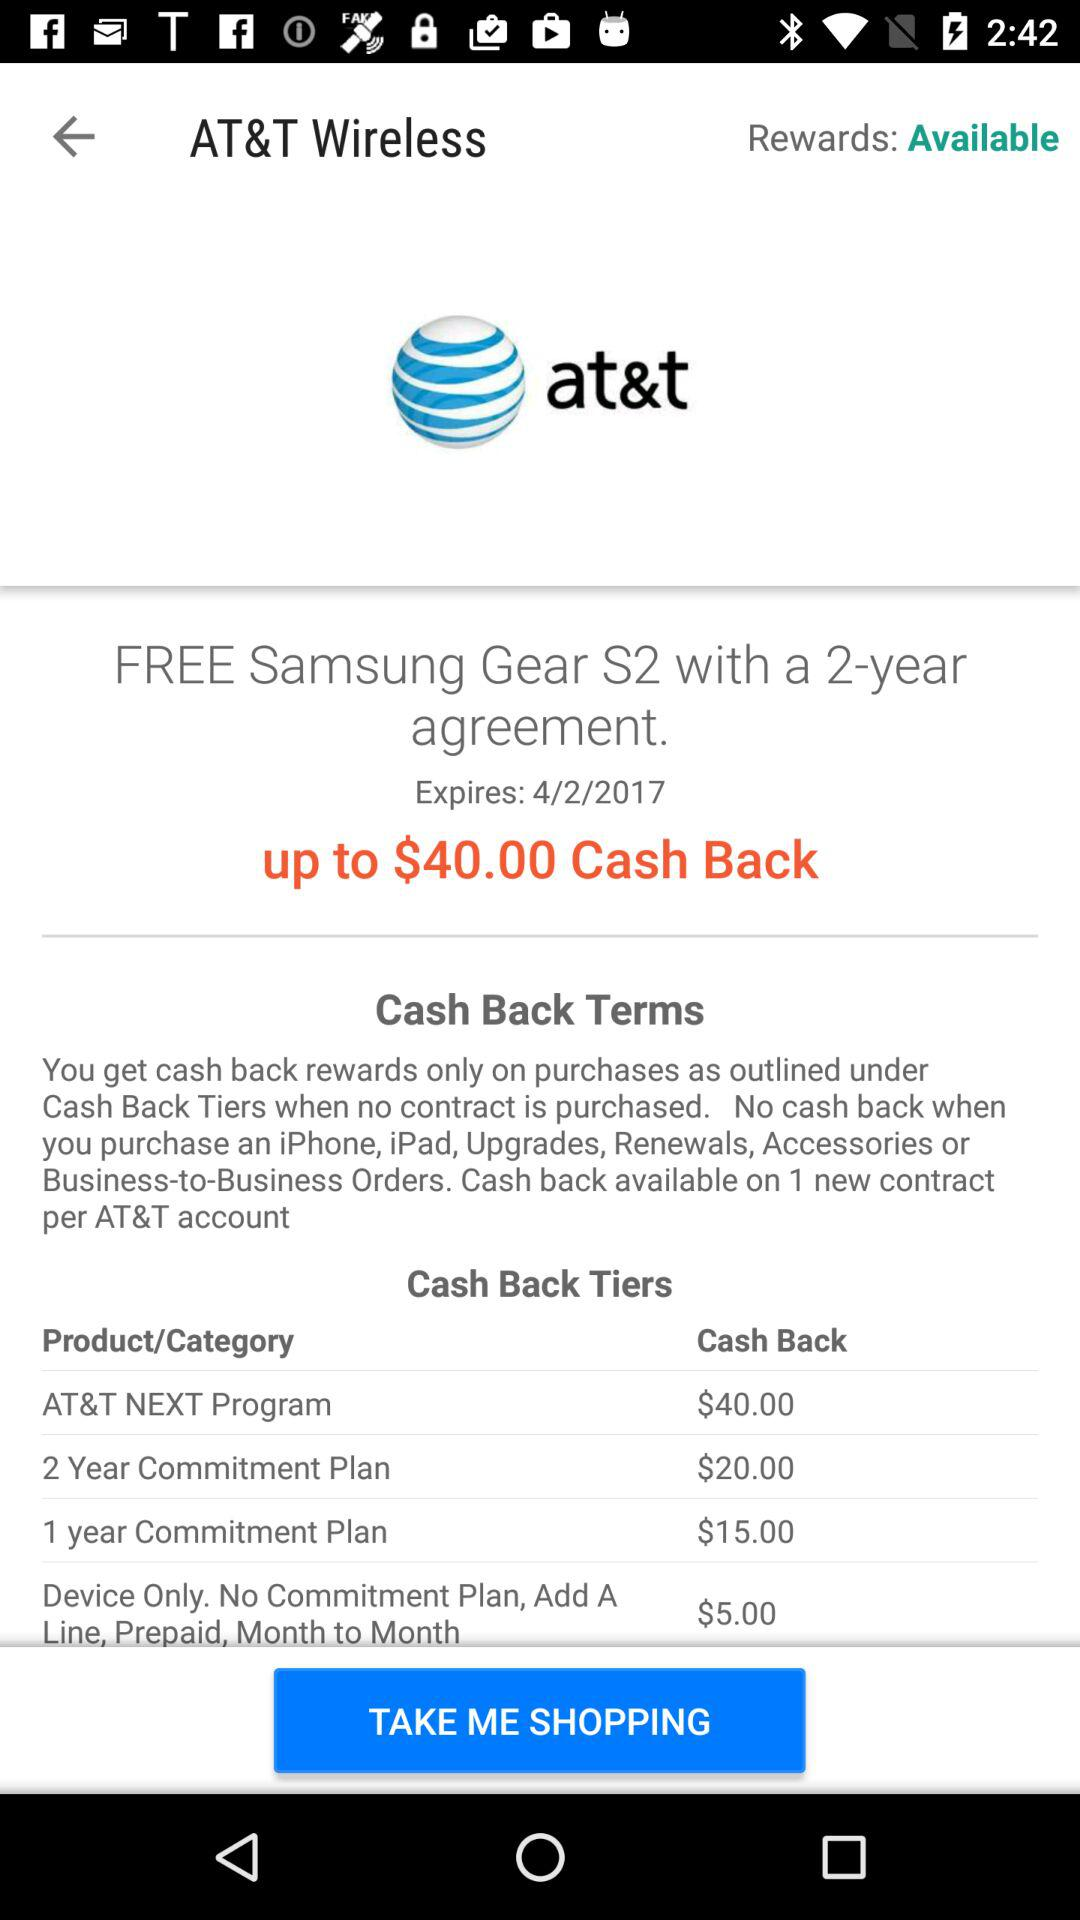How many dollars is the maximum cash back?
Answer the question using a single word or phrase. $40.00 